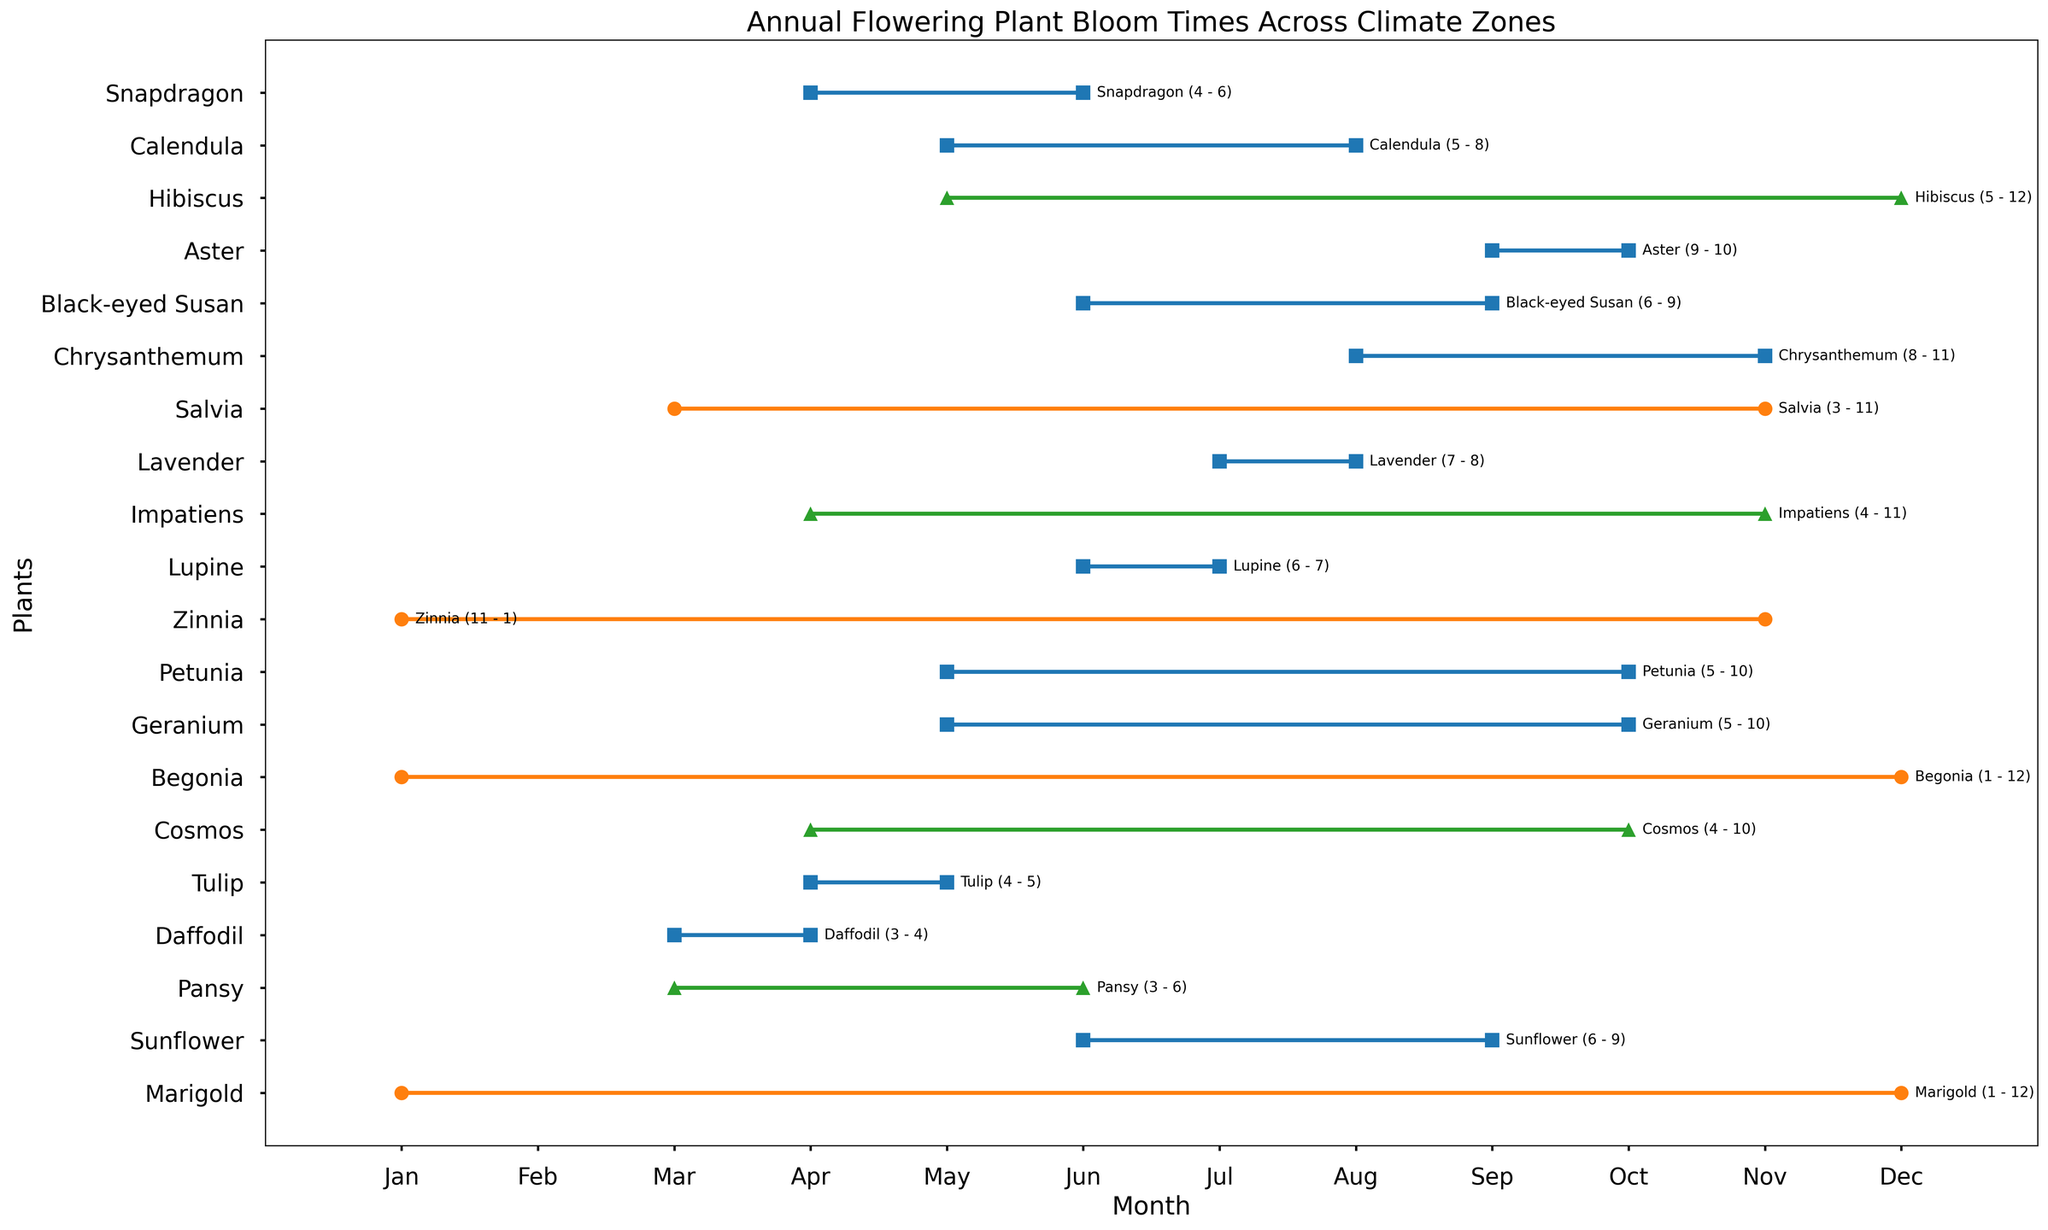Which plant blooms for the longest duration? By observing the length of the bars in the plot, we can see which plant has the longest span between its "Bloom_Start" and "Bloom_End". Marigold and Begonia both bloom from January to December, giving them the longest duration.
Answer: Marigold and Begonia Which plant in the temperate climate zone starts blooming in May? By looking at the annotated plant names and bloom periods, we find that Geranium, Petunia, and Calendula start blooming in May in the temperate climate zone.
Answer: Geranium, Petunia, and Calendula How many plants bloom in March in the subtropical zone? By checking the bloom periods for subtropical plants, Pansy, Cosmos, Impatiens, and Hibiscus all have blooms starting or spanning March.
Answer: 4 When does Lavender bloom, and in which climate zone is it found? According to the annotations, Lavender blooms between July and August in the temperate climate zone.
Answer: July - August, Temperate Which plant ends its bloom in the shortest timespan from its start, and what is that timespan? Comparing the durations in the annotations by subtracting "Bloom_Start" from "Bloom_End", Daffodil has the shortest bloom span (March to April), lasting only 1 month.
Answer: Daffodil, 1 month Which plant requires the highest total rainfall and what is the value? Although the plot focuses on bloom periods, we recall from the dataset that Salvia in the tropical zone requires the highest total rainfall, which is 1700 mm.
Answer: Salvia, 1700 mm Identify two plants that bloom during September together and their respective climate zones. Referring to the plots and annotations, Sunflower (Temperate) and Aster (Temperate) both bloom during September.
Answer: Sunflower (Temperate), Aster (Temperate) Compare the average temperatures for plants blooming in April. Which plant blooms at the highest average temperature? By examining the average temperatures of plants blooming in April (Tulip at 12, Cosmos at 25, Snapdragon at 18, Impatiens at 26), Impatiens blooms at the highest average temperature.
Answer: Impatiens, 26 degrees 